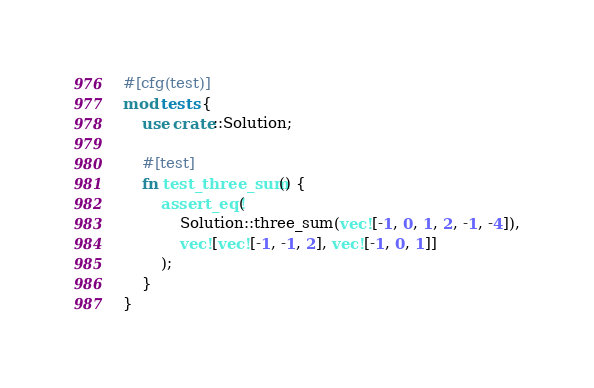Convert code to text. <code><loc_0><loc_0><loc_500><loc_500><_Rust_>
#[cfg(test)]
mod tests {
    use crate::Solution;

    #[test]
    fn test_three_sum() {
        assert_eq!(
            Solution::three_sum(vec![-1, 0, 1, 2, -1, -4]),
            vec![vec![-1, -1, 2], vec![-1, 0, 1]]
        );
    }
}
</code> 